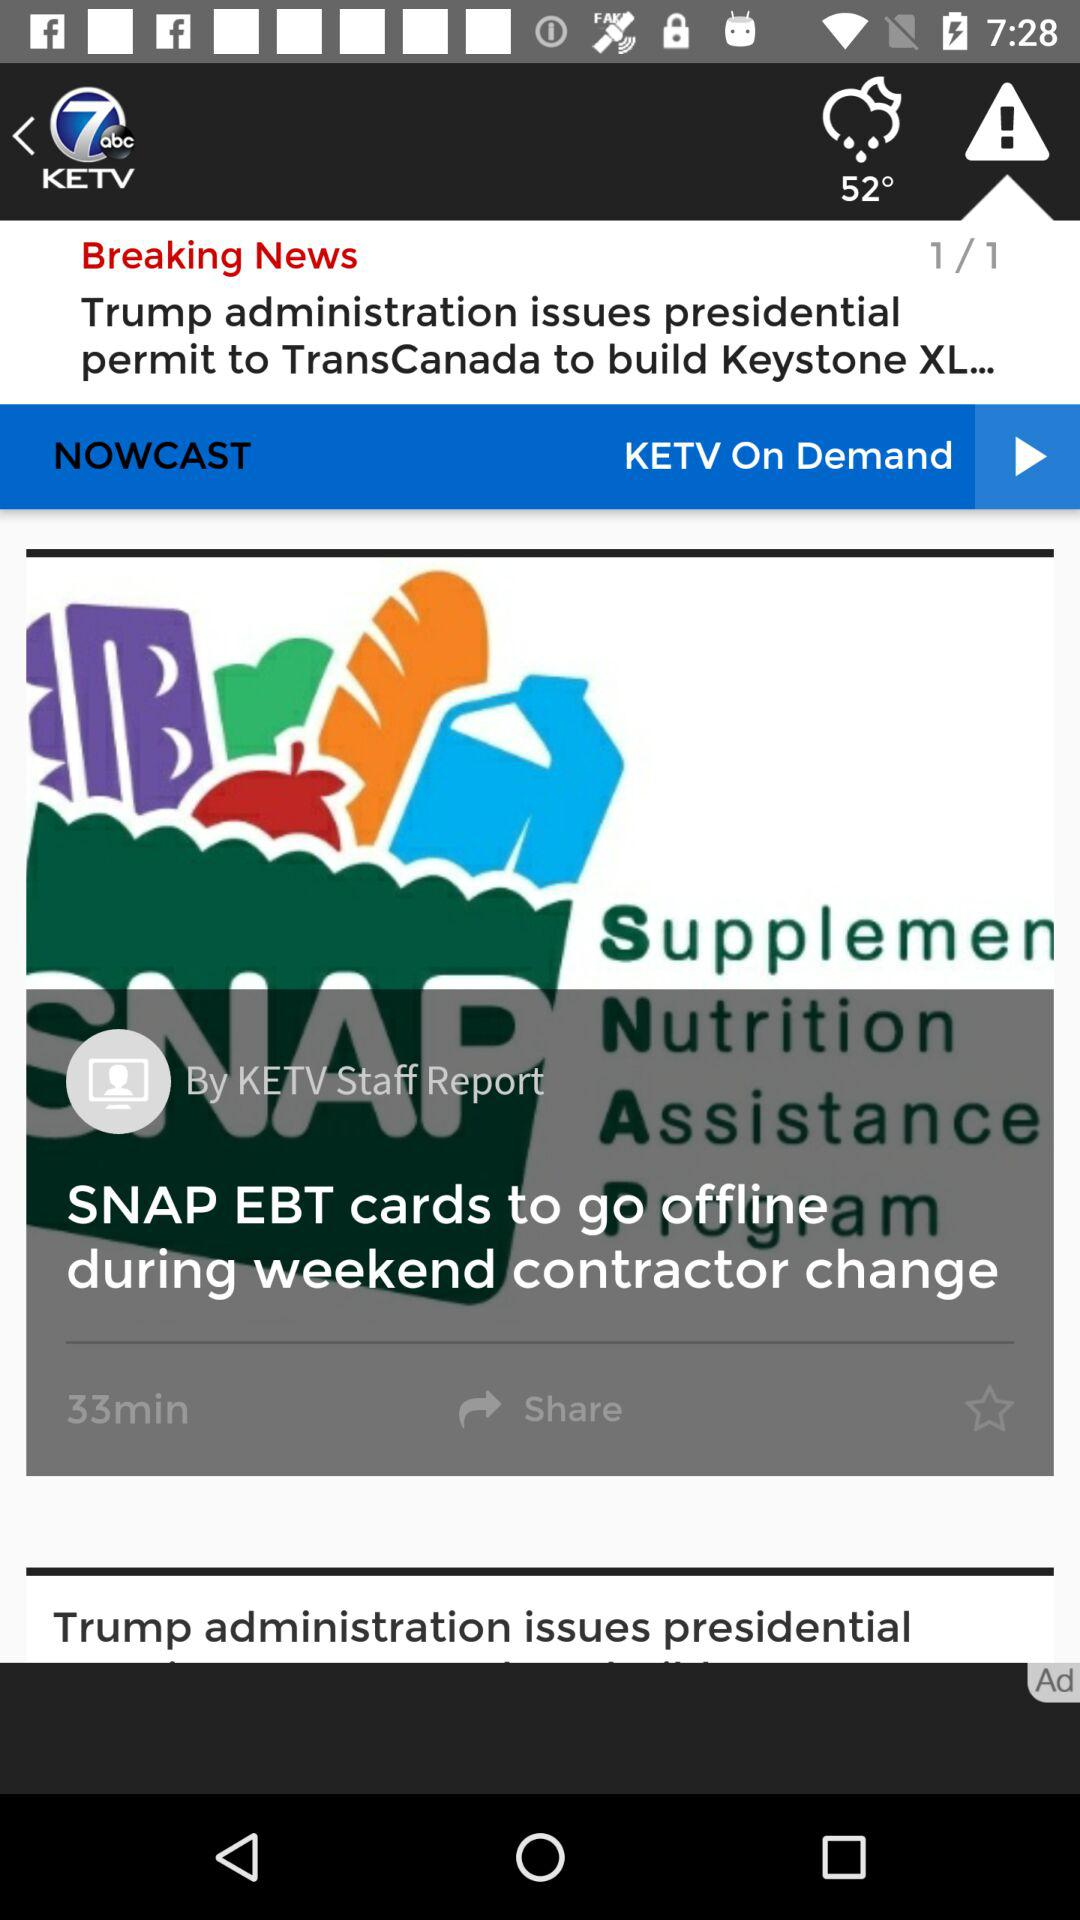Who is the author of the "SNAP EBT cards to go offline during weekend contractor change" article? The author of the "SNAP EBT cards to go offline during weekend contractor change" article is "KETV Staff". 